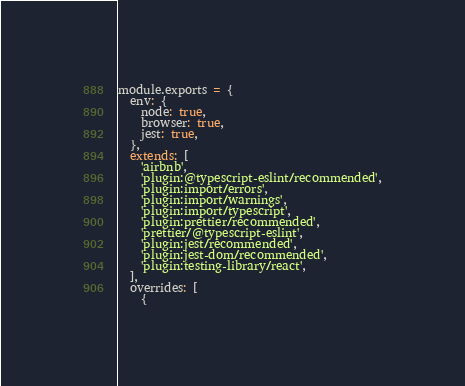<code> <loc_0><loc_0><loc_500><loc_500><_JavaScript_>module.exports = {
  env: {
    node: true,
    browser: true,
    jest: true,
  },
  extends: [
    'airbnb',
    'plugin:@typescript-eslint/recommended',
    'plugin:import/errors',
    'plugin:import/warnings',
    'plugin:import/typescript',
    'plugin:prettier/recommended',
    'prettier/@typescript-eslint',
    'plugin:jest/recommended',
    'plugin:jest-dom/recommended',
    'plugin:testing-library/react',
  ],
  overrides: [
    {</code> 